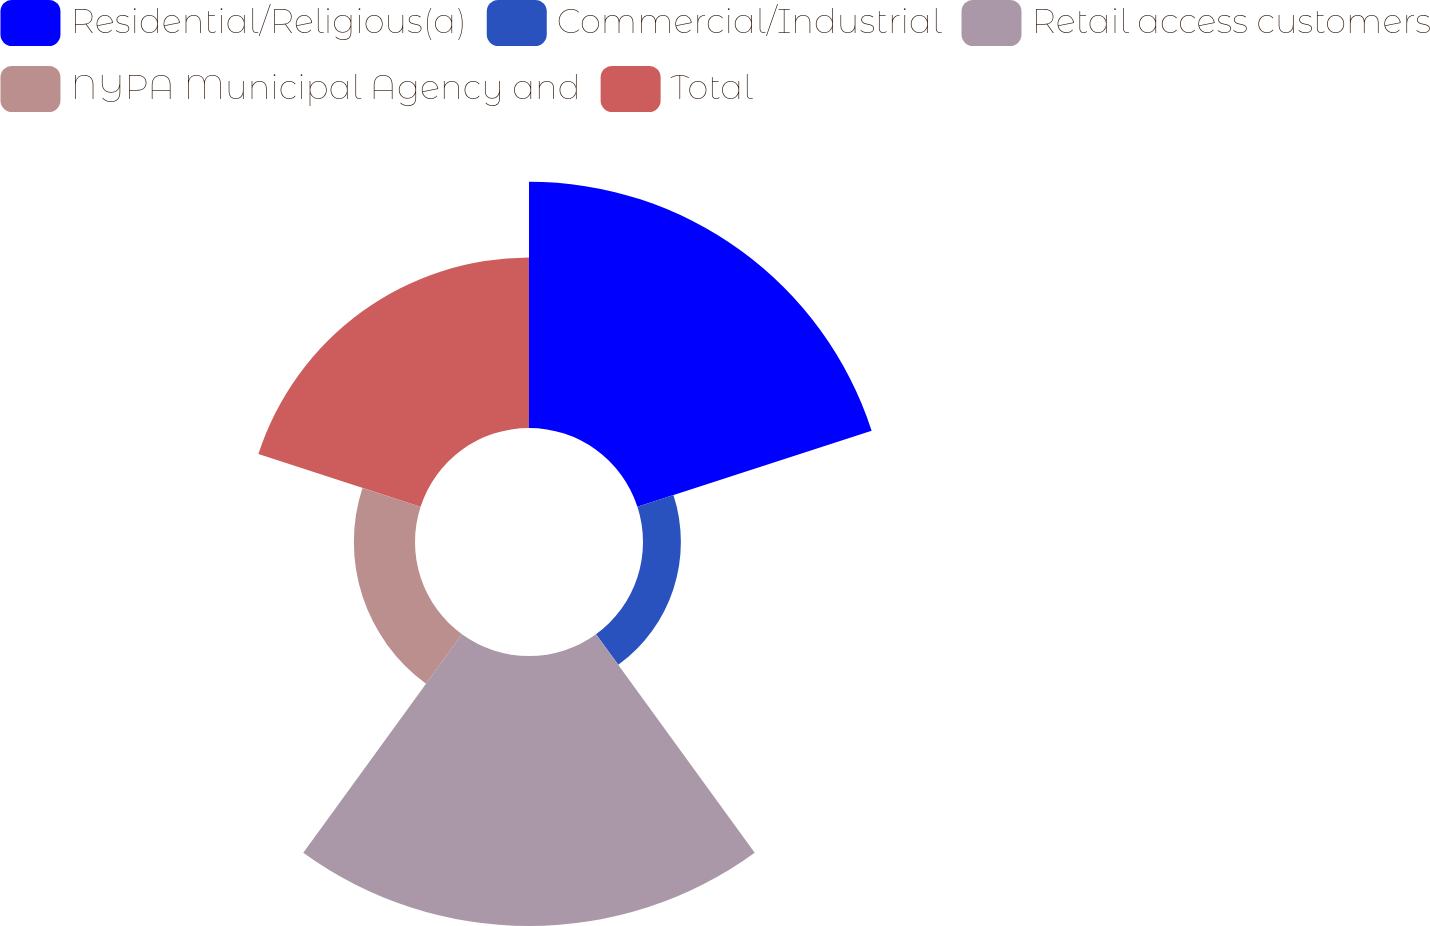Convert chart to OTSL. <chart><loc_0><loc_0><loc_500><loc_500><pie_chart><fcel>Residential/Religious(a)<fcel>Commercial/Industrial<fcel>Retail access customers<fcel>NYPA Municipal Agency and<fcel>Total<nl><fcel>31.34%<fcel>4.82%<fcel>34.36%<fcel>7.78%<fcel>21.7%<nl></chart> 